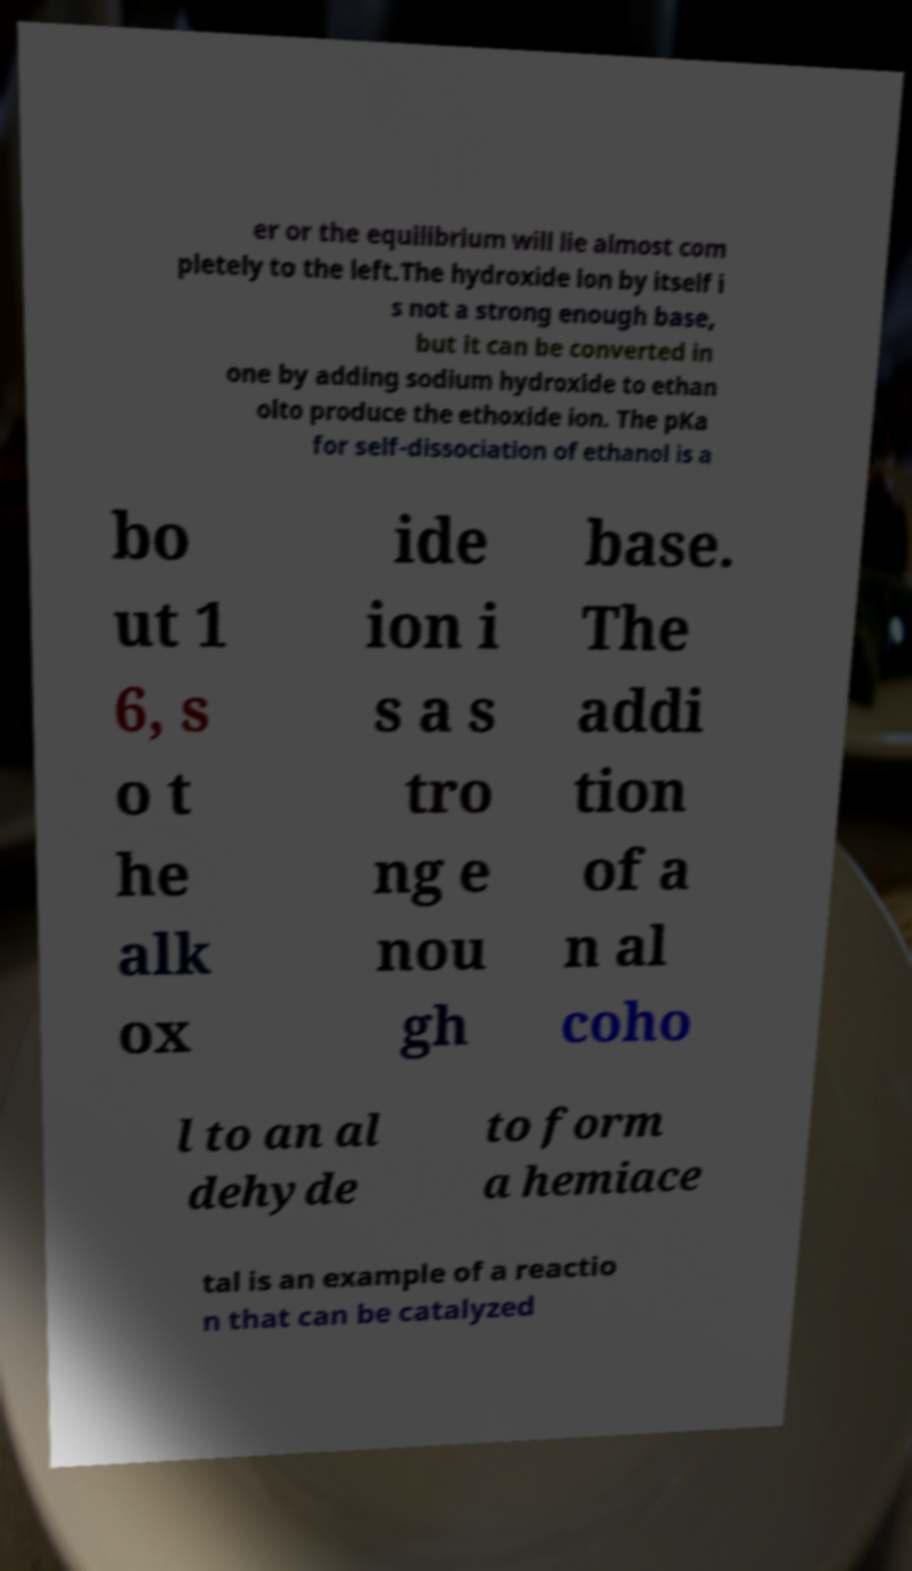What messages or text are displayed in this image? I need them in a readable, typed format. er or the equilibrium will lie almost com pletely to the left.The hydroxide ion by itself i s not a strong enough base, but it can be converted in one by adding sodium hydroxide to ethan olto produce the ethoxide ion. The pKa for self-dissociation of ethanol is a bo ut 1 6, s o t he alk ox ide ion i s a s tro ng e nou gh base. The addi tion of a n al coho l to an al dehyde to form a hemiace tal is an example of a reactio n that can be catalyzed 